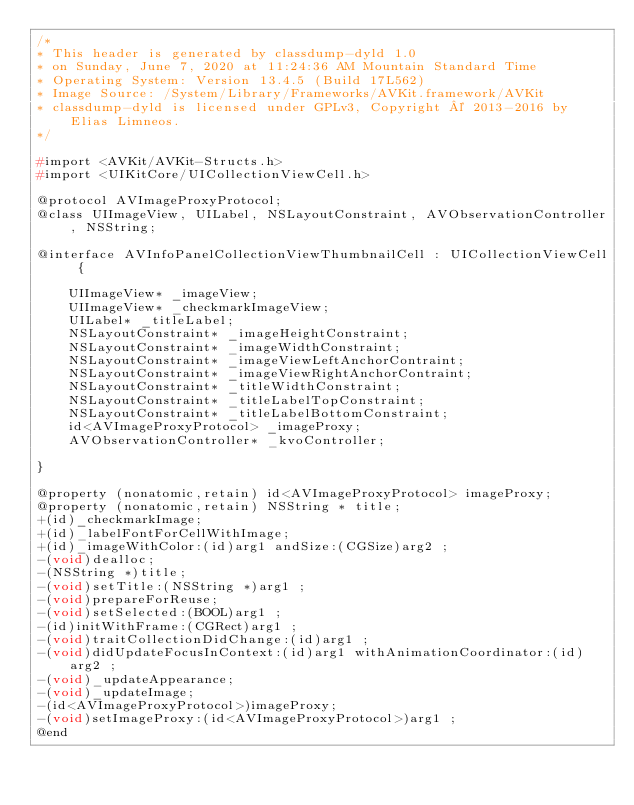Convert code to text. <code><loc_0><loc_0><loc_500><loc_500><_C_>/*
* This header is generated by classdump-dyld 1.0
* on Sunday, June 7, 2020 at 11:24:36 AM Mountain Standard Time
* Operating System: Version 13.4.5 (Build 17L562)
* Image Source: /System/Library/Frameworks/AVKit.framework/AVKit
* classdump-dyld is licensed under GPLv3, Copyright © 2013-2016 by Elias Limneos.
*/

#import <AVKit/AVKit-Structs.h>
#import <UIKitCore/UICollectionViewCell.h>

@protocol AVImageProxyProtocol;
@class UIImageView, UILabel, NSLayoutConstraint, AVObservationController, NSString;

@interface AVInfoPanelCollectionViewThumbnailCell : UICollectionViewCell {

	UIImageView* _imageView;
	UIImageView* _checkmarkImageView;
	UILabel* _titleLabel;
	NSLayoutConstraint* _imageHeightConstraint;
	NSLayoutConstraint* _imageWidthConstraint;
	NSLayoutConstraint* _imageViewLeftAnchorContraint;
	NSLayoutConstraint* _imageViewRightAnchorContraint;
	NSLayoutConstraint* _titleWidthConstraint;
	NSLayoutConstraint* _titleLabelTopConstraint;
	NSLayoutConstraint* _titleLabelBottomConstraint;
	id<AVImageProxyProtocol> _imageProxy;
	AVObservationController* _kvoController;

}

@property (nonatomic,retain) id<AVImageProxyProtocol> imageProxy; 
@property (nonatomic,retain) NSString * title; 
+(id)_checkmarkImage;
+(id)_labelFontForCellWithImage;
+(id)_imageWithColor:(id)arg1 andSize:(CGSize)arg2 ;
-(void)dealloc;
-(NSString *)title;
-(void)setTitle:(NSString *)arg1 ;
-(void)prepareForReuse;
-(void)setSelected:(BOOL)arg1 ;
-(id)initWithFrame:(CGRect)arg1 ;
-(void)traitCollectionDidChange:(id)arg1 ;
-(void)didUpdateFocusInContext:(id)arg1 withAnimationCoordinator:(id)arg2 ;
-(void)_updateAppearance;
-(void)_updateImage;
-(id<AVImageProxyProtocol>)imageProxy;
-(void)setImageProxy:(id<AVImageProxyProtocol>)arg1 ;
@end

</code> 